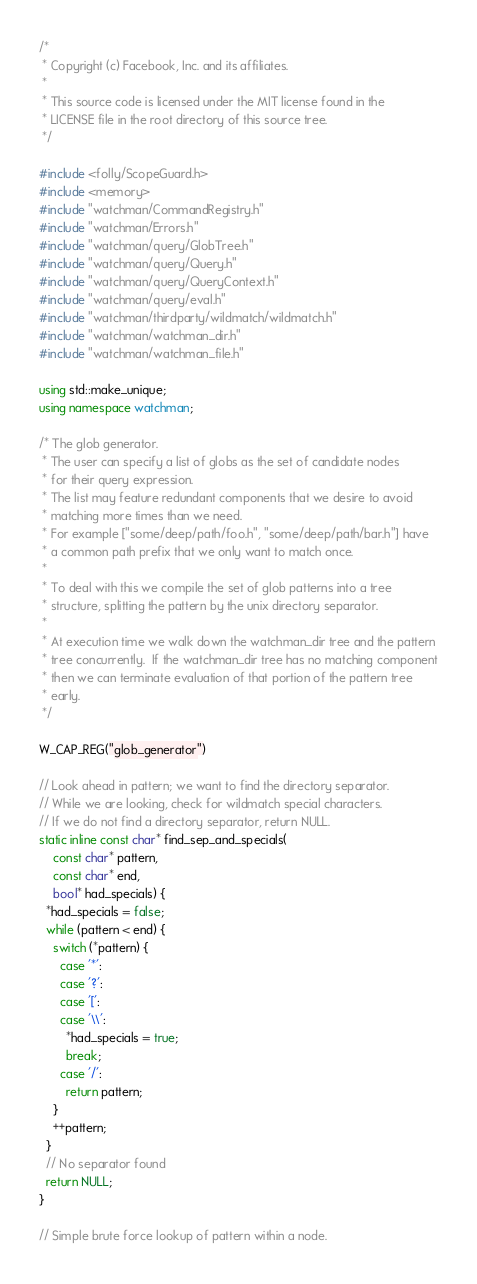Convert code to text. <code><loc_0><loc_0><loc_500><loc_500><_C++_>/*
 * Copyright (c) Facebook, Inc. and its affiliates.
 *
 * This source code is licensed under the MIT license found in the
 * LICENSE file in the root directory of this source tree.
 */

#include <folly/ScopeGuard.h>
#include <memory>
#include "watchman/CommandRegistry.h"
#include "watchman/Errors.h"
#include "watchman/query/GlobTree.h"
#include "watchman/query/Query.h"
#include "watchman/query/QueryContext.h"
#include "watchman/query/eval.h"
#include "watchman/thirdparty/wildmatch/wildmatch.h"
#include "watchman/watchman_dir.h"
#include "watchman/watchman_file.h"

using std::make_unique;
using namespace watchman;

/* The glob generator.
 * The user can specify a list of globs as the set of candidate nodes
 * for their query expression.
 * The list may feature redundant components that we desire to avoid
 * matching more times than we need.
 * For example ["some/deep/path/foo.h", "some/deep/path/bar.h"] have
 * a common path prefix that we only want to match once.
 *
 * To deal with this we compile the set of glob patterns into a tree
 * structure, splitting the pattern by the unix directory separator.
 *
 * At execution time we walk down the watchman_dir tree and the pattern
 * tree concurrently.  If the watchman_dir tree has no matching component
 * then we can terminate evaluation of that portion of the pattern tree
 * early.
 */

W_CAP_REG("glob_generator")

// Look ahead in pattern; we want to find the directory separator.
// While we are looking, check for wildmatch special characters.
// If we do not find a directory separator, return NULL.
static inline const char* find_sep_and_specials(
    const char* pattern,
    const char* end,
    bool* had_specials) {
  *had_specials = false;
  while (pattern < end) {
    switch (*pattern) {
      case '*':
      case '?':
      case '[':
      case '\\':
        *had_specials = true;
        break;
      case '/':
        return pattern;
    }
    ++pattern;
  }
  // No separator found
  return NULL;
}

// Simple brute force lookup of pattern within a node.</code> 